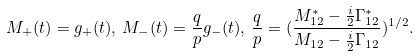<formula> <loc_0><loc_0><loc_500><loc_500>M _ { + } ( t ) = g _ { + } ( t ) , \, M _ { - } ( t ) = \frac { q } { p } g _ { - } ( t ) , \, \frac { q } { p } = ( \frac { M ^ { * } _ { 1 2 } - \frac { i } { 2 } \Gamma ^ { * } _ { 1 2 } } { M _ { 1 2 } - \frac { i } { 2 } \Gamma _ { 1 2 } } ) ^ { 1 / 2 } .</formula> 